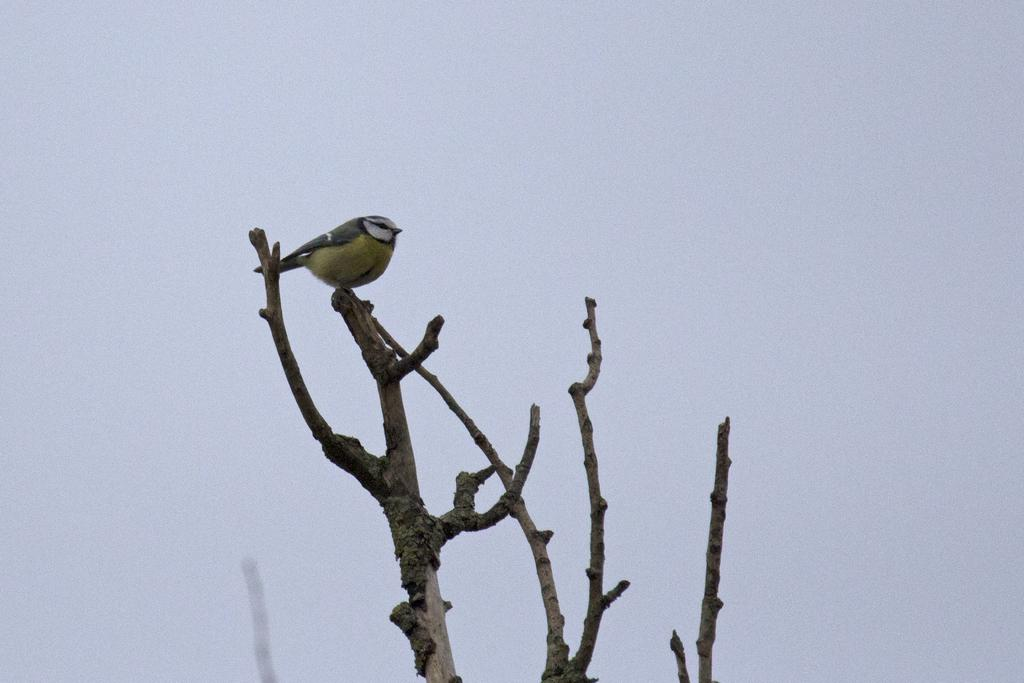What can be seen in the background of the image? The sky is visible in the image. What part of a tree is visible in the image? There is a tree stem in the image. What type of animal is present in the image? A bird is present in the image. What type of drum can be seen in the image? There is no drum present in the image. What is the bird doing with its chin in the image? The bird does not have a chin, and there is no chin-related activity depicted in the image. 